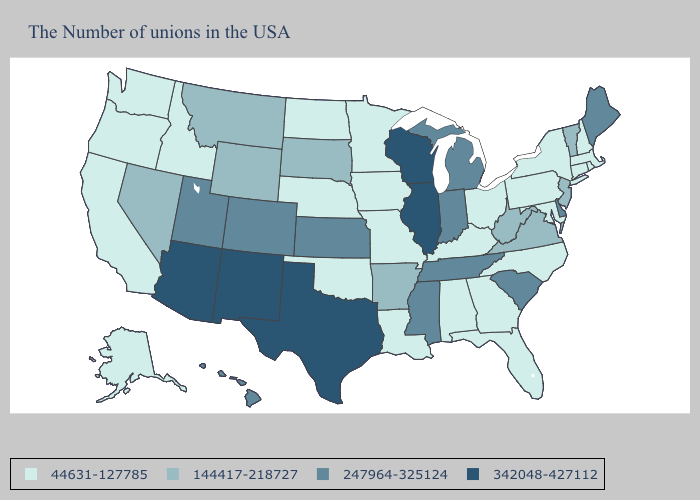Name the states that have a value in the range 144417-218727?
Be succinct. Vermont, New Jersey, Virginia, West Virginia, Arkansas, South Dakota, Wyoming, Montana, Nevada. Does Florida have the highest value in the South?
Concise answer only. No. Which states have the lowest value in the MidWest?
Write a very short answer. Ohio, Missouri, Minnesota, Iowa, Nebraska, North Dakota. What is the highest value in states that border Kentucky?
Give a very brief answer. 342048-427112. What is the highest value in states that border Wyoming?
Answer briefly. 247964-325124. What is the value of New Jersey?
Short answer required. 144417-218727. Name the states that have a value in the range 144417-218727?
Give a very brief answer. Vermont, New Jersey, Virginia, West Virginia, Arkansas, South Dakota, Wyoming, Montana, Nevada. What is the lowest value in the USA?
Keep it brief. 44631-127785. Does the first symbol in the legend represent the smallest category?
Give a very brief answer. Yes. Name the states that have a value in the range 44631-127785?
Answer briefly. Massachusetts, Rhode Island, New Hampshire, Connecticut, New York, Maryland, Pennsylvania, North Carolina, Ohio, Florida, Georgia, Kentucky, Alabama, Louisiana, Missouri, Minnesota, Iowa, Nebraska, Oklahoma, North Dakota, Idaho, California, Washington, Oregon, Alaska. What is the value of Wyoming?
Keep it brief. 144417-218727. Does Idaho have a lower value than Missouri?
Give a very brief answer. No. Is the legend a continuous bar?
Give a very brief answer. No. How many symbols are there in the legend?
Quick response, please. 4. What is the value of Idaho?
Give a very brief answer. 44631-127785. 